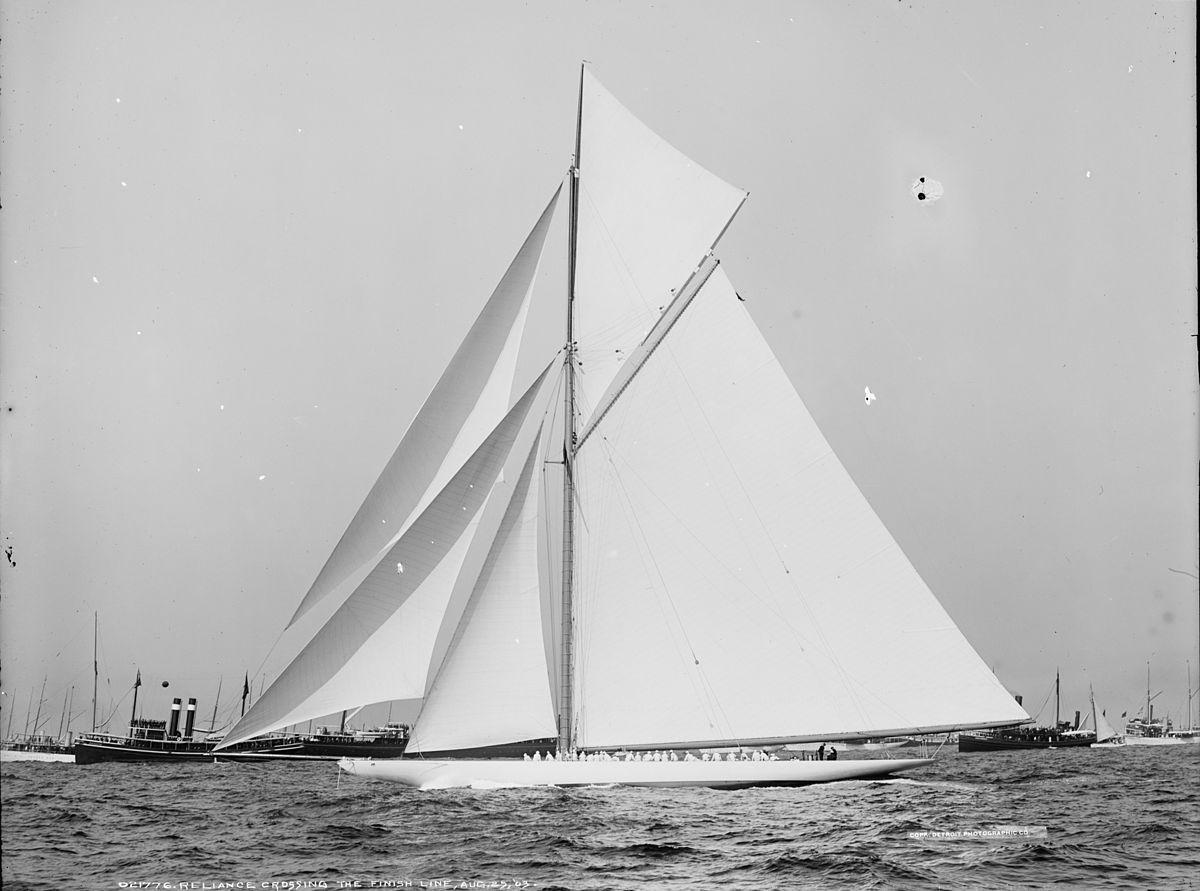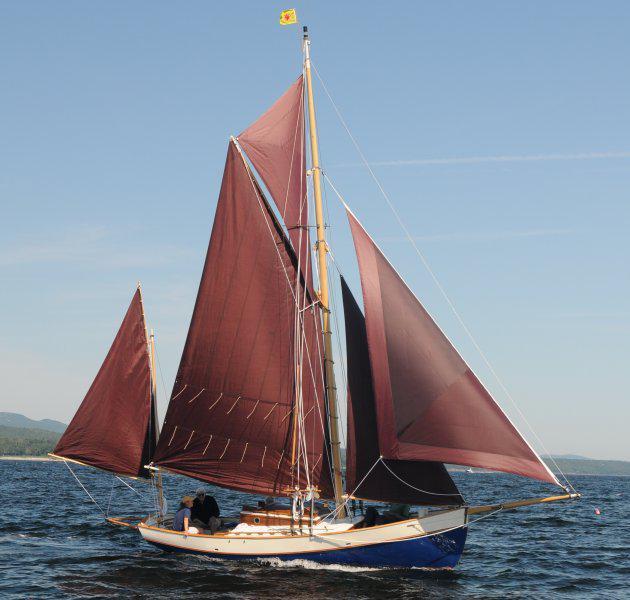The first image is the image on the left, the second image is the image on the right. Assess this claim about the two images: "One of the images shows a sail with a number on it.". Correct or not? Answer yes or no. No. The first image is the image on the left, the second image is the image on the right. Analyze the images presented: Is the assertion "A hillside at least half the height of the whole image is in the background of a scene with a sailing boat." valid? Answer yes or no. No. 